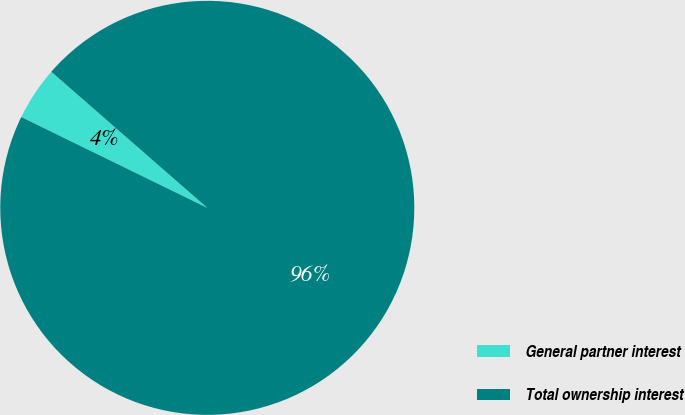Convert chart. <chart><loc_0><loc_0><loc_500><loc_500><pie_chart><fcel>General partner interest<fcel>Total ownership interest<nl><fcel>4.19%<fcel>95.81%<nl></chart> 